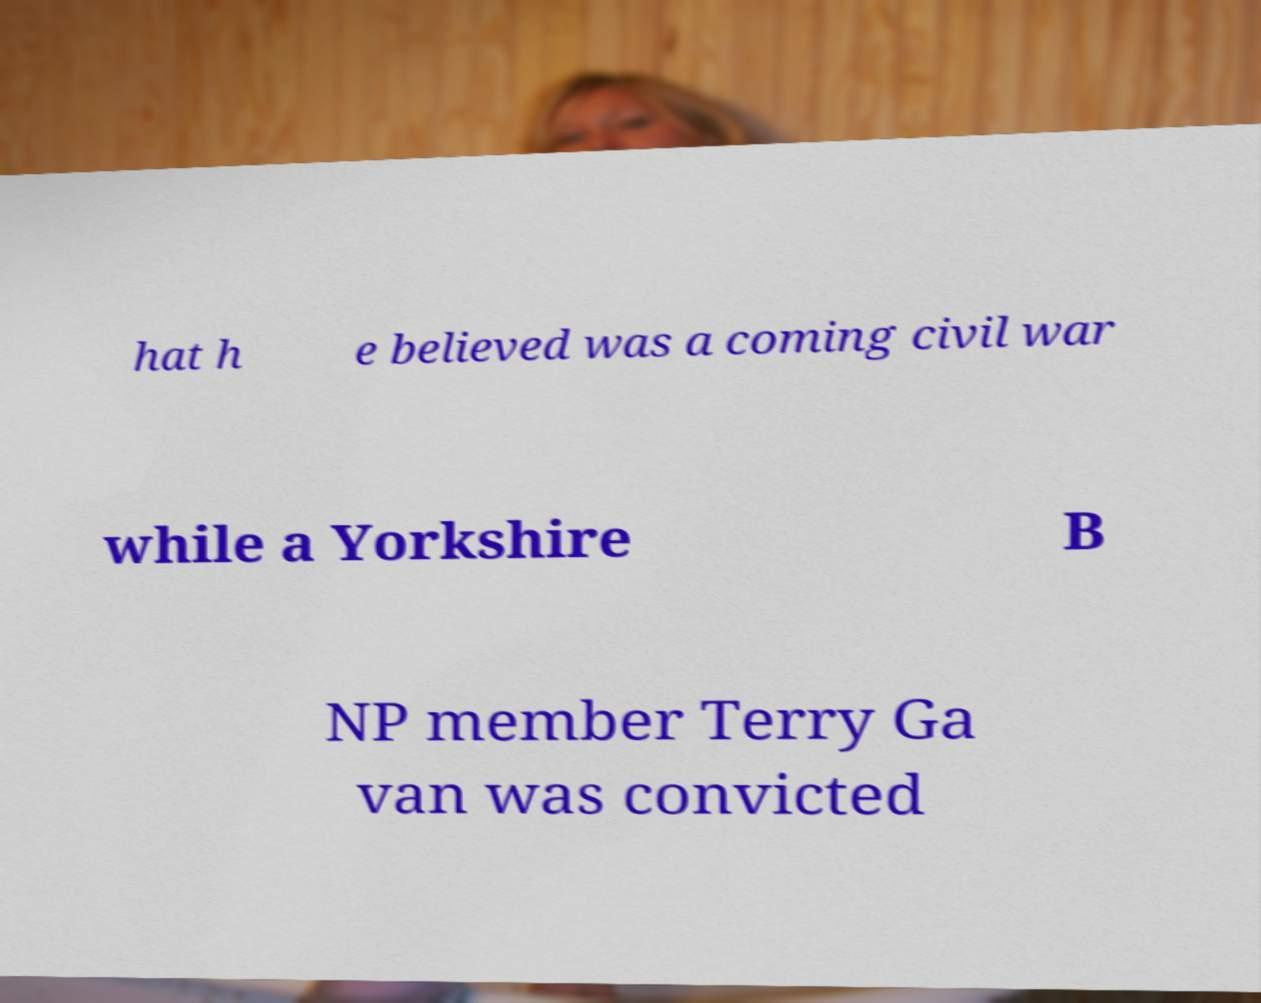Can you read and provide the text displayed in the image?This photo seems to have some interesting text. Can you extract and type it out for me? hat h e believed was a coming civil war while a Yorkshire B NP member Terry Ga van was convicted 